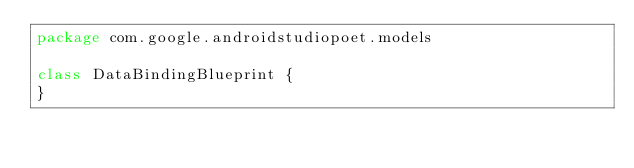Convert code to text. <code><loc_0><loc_0><loc_500><loc_500><_Kotlin_>package com.google.androidstudiopoet.models

class DataBindingBlueprint {
}</code> 